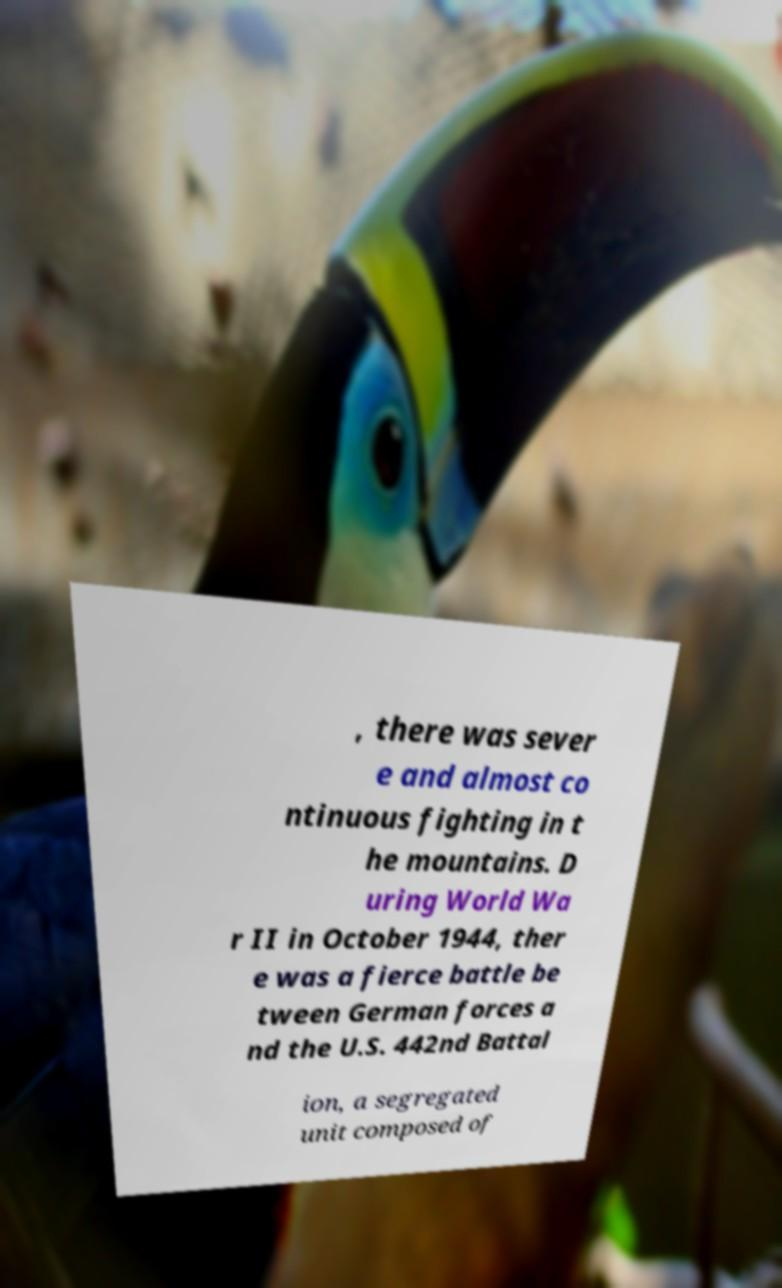For documentation purposes, I need the text within this image transcribed. Could you provide that? , there was sever e and almost co ntinuous fighting in t he mountains. D uring World Wa r II in October 1944, ther e was a fierce battle be tween German forces a nd the U.S. 442nd Battal ion, a segregated unit composed of 